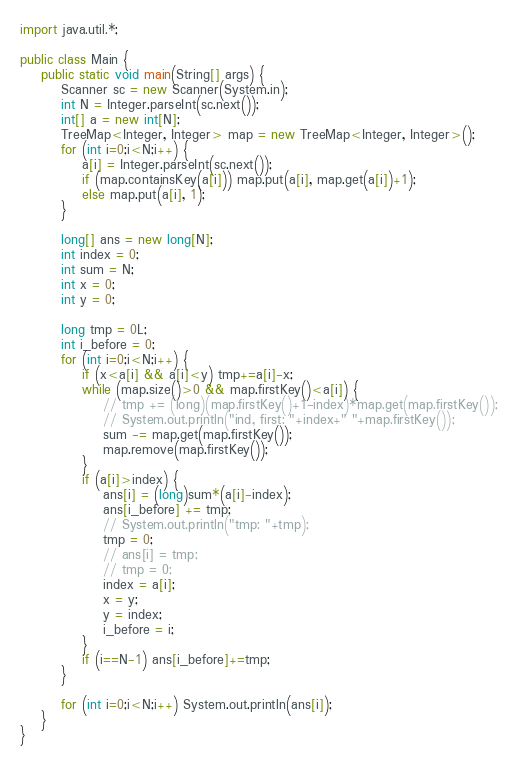<code> <loc_0><loc_0><loc_500><loc_500><_Java_>import java.util.*;

public class Main {
    public static void main(String[] args) {
        Scanner sc = new Scanner(System.in);
        int N = Integer.parseInt(sc.next());
        int[] a = new int[N];
        TreeMap<Integer, Integer> map = new TreeMap<Integer, Integer>();
        for (int i=0;i<N;i++) {
            a[i] = Integer.parseInt(sc.next());
            if (map.containsKey(a[i])) map.put(a[i], map.get(a[i])+1);
            else map.put(a[i], 1);
        }

        long[] ans = new long[N];
        int index = 0;
        int sum = N;
        int x = 0;
        int y = 0;

        long tmp = 0L;
        int i_before = 0;
        for (int i=0;i<N;i++) {
            if (x<a[i] && a[i]<y) tmp+=a[i]-x;
            while (map.size()>0 && map.firstKey()<a[i]) {
                // tmp += (long)(map.firstKey()+1-index)*map.get(map.firstKey());
                // System.out.println("ind, first: "+index+" "+map.firstKey());
                sum -= map.get(map.firstKey());
                map.remove(map.firstKey());
            }
            if (a[i]>index) {
                ans[i] = (long)sum*(a[i]-index);
                ans[i_before] += tmp;
                // System.out.println("tmp: "+tmp);
                tmp = 0;
                // ans[i] = tmp;
                // tmp = 0;
                index = a[i];
                x = y;
                y = index;
                i_before = i;
            }
            if (i==N-1) ans[i_before]+=tmp;
        }

        for (int i=0;i<N;i++) System.out.println(ans[i]);
    }
}</code> 